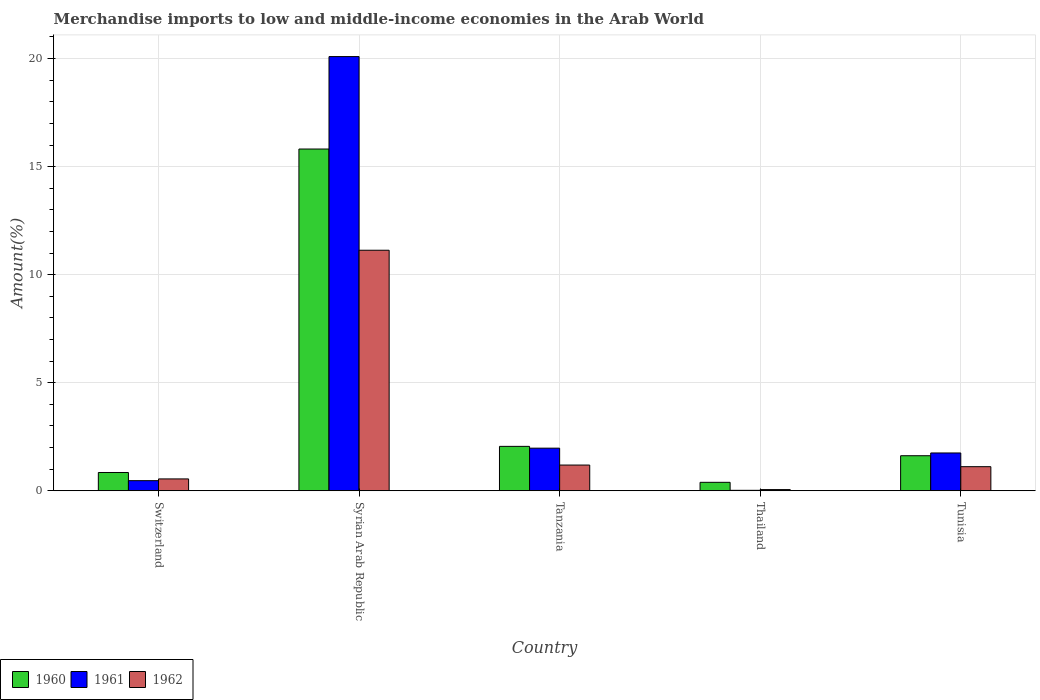How many different coloured bars are there?
Ensure brevity in your answer.  3. How many groups of bars are there?
Provide a succinct answer. 5. Are the number of bars on each tick of the X-axis equal?
Offer a very short reply. Yes. How many bars are there on the 4th tick from the right?
Provide a succinct answer. 3. What is the label of the 3rd group of bars from the left?
Ensure brevity in your answer.  Tanzania. In how many cases, is the number of bars for a given country not equal to the number of legend labels?
Keep it short and to the point. 0. What is the percentage of amount earned from merchandise imports in 1960 in Thailand?
Ensure brevity in your answer.  0.39. Across all countries, what is the maximum percentage of amount earned from merchandise imports in 1960?
Offer a terse response. 15.81. Across all countries, what is the minimum percentage of amount earned from merchandise imports in 1960?
Ensure brevity in your answer.  0.39. In which country was the percentage of amount earned from merchandise imports in 1962 maximum?
Give a very brief answer. Syrian Arab Republic. In which country was the percentage of amount earned from merchandise imports in 1960 minimum?
Your answer should be compact. Thailand. What is the total percentage of amount earned from merchandise imports in 1960 in the graph?
Offer a terse response. 20.73. What is the difference between the percentage of amount earned from merchandise imports in 1962 in Tanzania and that in Tunisia?
Provide a succinct answer. 0.08. What is the difference between the percentage of amount earned from merchandise imports in 1961 in Switzerland and the percentage of amount earned from merchandise imports in 1962 in Tunisia?
Provide a succinct answer. -0.65. What is the average percentage of amount earned from merchandise imports in 1961 per country?
Provide a short and direct response. 4.86. What is the difference between the percentage of amount earned from merchandise imports of/in 1962 and percentage of amount earned from merchandise imports of/in 1960 in Tunisia?
Ensure brevity in your answer.  -0.51. What is the ratio of the percentage of amount earned from merchandise imports in 1960 in Syrian Arab Republic to that in Tunisia?
Provide a succinct answer. 9.75. Is the percentage of amount earned from merchandise imports in 1960 in Syrian Arab Republic less than that in Tunisia?
Provide a short and direct response. No. Is the difference between the percentage of amount earned from merchandise imports in 1962 in Syrian Arab Republic and Tunisia greater than the difference between the percentage of amount earned from merchandise imports in 1960 in Syrian Arab Republic and Tunisia?
Ensure brevity in your answer.  No. What is the difference between the highest and the second highest percentage of amount earned from merchandise imports in 1962?
Keep it short and to the point. -9.94. What is the difference between the highest and the lowest percentage of amount earned from merchandise imports in 1960?
Provide a short and direct response. 15.42. In how many countries, is the percentage of amount earned from merchandise imports in 1962 greater than the average percentage of amount earned from merchandise imports in 1962 taken over all countries?
Your answer should be compact. 1. Is the sum of the percentage of amount earned from merchandise imports in 1961 in Thailand and Tunisia greater than the maximum percentage of amount earned from merchandise imports in 1960 across all countries?
Your answer should be very brief. No. Is it the case that in every country, the sum of the percentage of amount earned from merchandise imports in 1962 and percentage of amount earned from merchandise imports in 1960 is greater than the percentage of amount earned from merchandise imports in 1961?
Your answer should be very brief. Yes. How many countries are there in the graph?
Provide a succinct answer. 5. Does the graph contain any zero values?
Offer a very short reply. No. Does the graph contain grids?
Your response must be concise. Yes. How are the legend labels stacked?
Provide a short and direct response. Horizontal. What is the title of the graph?
Give a very brief answer. Merchandise imports to low and middle-income economies in the Arab World. Does "2003" appear as one of the legend labels in the graph?
Provide a short and direct response. No. What is the label or title of the X-axis?
Offer a very short reply. Country. What is the label or title of the Y-axis?
Make the answer very short. Amount(%). What is the Amount(%) of 1960 in Switzerland?
Offer a terse response. 0.85. What is the Amount(%) of 1961 in Switzerland?
Your response must be concise. 0.47. What is the Amount(%) of 1962 in Switzerland?
Offer a terse response. 0.55. What is the Amount(%) in 1960 in Syrian Arab Republic?
Your answer should be compact. 15.81. What is the Amount(%) in 1961 in Syrian Arab Republic?
Keep it short and to the point. 20.09. What is the Amount(%) of 1962 in Syrian Arab Republic?
Offer a very short reply. 11.13. What is the Amount(%) in 1960 in Tanzania?
Offer a very short reply. 2.06. What is the Amount(%) of 1961 in Tanzania?
Offer a terse response. 1.97. What is the Amount(%) of 1962 in Tanzania?
Offer a terse response. 1.19. What is the Amount(%) of 1960 in Thailand?
Your response must be concise. 0.39. What is the Amount(%) of 1961 in Thailand?
Offer a very short reply. 0.02. What is the Amount(%) in 1962 in Thailand?
Provide a succinct answer. 0.06. What is the Amount(%) in 1960 in Tunisia?
Provide a short and direct response. 1.62. What is the Amount(%) of 1961 in Tunisia?
Ensure brevity in your answer.  1.75. What is the Amount(%) of 1962 in Tunisia?
Offer a terse response. 1.12. Across all countries, what is the maximum Amount(%) of 1960?
Make the answer very short. 15.81. Across all countries, what is the maximum Amount(%) of 1961?
Your answer should be compact. 20.09. Across all countries, what is the maximum Amount(%) of 1962?
Give a very brief answer. 11.13. Across all countries, what is the minimum Amount(%) of 1960?
Your response must be concise. 0.39. Across all countries, what is the minimum Amount(%) of 1961?
Your response must be concise. 0.02. Across all countries, what is the minimum Amount(%) of 1962?
Your response must be concise. 0.06. What is the total Amount(%) of 1960 in the graph?
Offer a very short reply. 20.73. What is the total Amount(%) in 1961 in the graph?
Keep it short and to the point. 24.3. What is the total Amount(%) in 1962 in the graph?
Your answer should be very brief. 14.04. What is the difference between the Amount(%) of 1960 in Switzerland and that in Syrian Arab Republic?
Provide a short and direct response. -14.97. What is the difference between the Amount(%) in 1961 in Switzerland and that in Syrian Arab Republic?
Make the answer very short. -19.62. What is the difference between the Amount(%) of 1962 in Switzerland and that in Syrian Arab Republic?
Give a very brief answer. -10.58. What is the difference between the Amount(%) in 1960 in Switzerland and that in Tanzania?
Offer a very short reply. -1.21. What is the difference between the Amount(%) in 1961 in Switzerland and that in Tanzania?
Keep it short and to the point. -1.5. What is the difference between the Amount(%) of 1962 in Switzerland and that in Tanzania?
Give a very brief answer. -0.64. What is the difference between the Amount(%) in 1960 in Switzerland and that in Thailand?
Ensure brevity in your answer.  0.45. What is the difference between the Amount(%) of 1961 in Switzerland and that in Thailand?
Provide a succinct answer. 0.45. What is the difference between the Amount(%) in 1962 in Switzerland and that in Thailand?
Provide a short and direct response. 0.49. What is the difference between the Amount(%) of 1960 in Switzerland and that in Tunisia?
Offer a very short reply. -0.78. What is the difference between the Amount(%) in 1961 in Switzerland and that in Tunisia?
Offer a very short reply. -1.28. What is the difference between the Amount(%) of 1962 in Switzerland and that in Tunisia?
Your response must be concise. -0.57. What is the difference between the Amount(%) of 1960 in Syrian Arab Republic and that in Tanzania?
Give a very brief answer. 13.76. What is the difference between the Amount(%) of 1961 in Syrian Arab Republic and that in Tanzania?
Provide a short and direct response. 18.12. What is the difference between the Amount(%) of 1962 in Syrian Arab Republic and that in Tanzania?
Give a very brief answer. 9.94. What is the difference between the Amount(%) in 1960 in Syrian Arab Republic and that in Thailand?
Ensure brevity in your answer.  15.42. What is the difference between the Amount(%) of 1961 in Syrian Arab Republic and that in Thailand?
Your answer should be very brief. 20.07. What is the difference between the Amount(%) in 1962 in Syrian Arab Republic and that in Thailand?
Provide a succinct answer. 11.07. What is the difference between the Amount(%) of 1960 in Syrian Arab Republic and that in Tunisia?
Make the answer very short. 14.19. What is the difference between the Amount(%) of 1961 in Syrian Arab Republic and that in Tunisia?
Keep it short and to the point. 18.34. What is the difference between the Amount(%) in 1962 in Syrian Arab Republic and that in Tunisia?
Keep it short and to the point. 10.01. What is the difference between the Amount(%) of 1960 in Tanzania and that in Thailand?
Make the answer very short. 1.66. What is the difference between the Amount(%) of 1961 in Tanzania and that in Thailand?
Give a very brief answer. 1.95. What is the difference between the Amount(%) in 1962 in Tanzania and that in Thailand?
Give a very brief answer. 1.13. What is the difference between the Amount(%) of 1960 in Tanzania and that in Tunisia?
Offer a terse response. 0.43. What is the difference between the Amount(%) in 1961 in Tanzania and that in Tunisia?
Your response must be concise. 0.22. What is the difference between the Amount(%) in 1962 in Tanzania and that in Tunisia?
Ensure brevity in your answer.  0.08. What is the difference between the Amount(%) of 1960 in Thailand and that in Tunisia?
Your answer should be compact. -1.23. What is the difference between the Amount(%) in 1961 in Thailand and that in Tunisia?
Make the answer very short. -1.73. What is the difference between the Amount(%) of 1962 in Thailand and that in Tunisia?
Make the answer very short. -1.06. What is the difference between the Amount(%) in 1960 in Switzerland and the Amount(%) in 1961 in Syrian Arab Republic?
Offer a very short reply. -19.25. What is the difference between the Amount(%) in 1960 in Switzerland and the Amount(%) in 1962 in Syrian Arab Republic?
Offer a very short reply. -10.28. What is the difference between the Amount(%) of 1961 in Switzerland and the Amount(%) of 1962 in Syrian Arab Republic?
Give a very brief answer. -10.66. What is the difference between the Amount(%) of 1960 in Switzerland and the Amount(%) of 1961 in Tanzania?
Keep it short and to the point. -1.13. What is the difference between the Amount(%) of 1960 in Switzerland and the Amount(%) of 1962 in Tanzania?
Provide a succinct answer. -0.34. What is the difference between the Amount(%) in 1961 in Switzerland and the Amount(%) in 1962 in Tanzania?
Your response must be concise. -0.72. What is the difference between the Amount(%) of 1960 in Switzerland and the Amount(%) of 1961 in Thailand?
Your response must be concise. 0.82. What is the difference between the Amount(%) in 1960 in Switzerland and the Amount(%) in 1962 in Thailand?
Provide a succinct answer. 0.79. What is the difference between the Amount(%) of 1961 in Switzerland and the Amount(%) of 1962 in Thailand?
Provide a short and direct response. 0.41. What is the difference between the Amount(%) of 1960 in Switzerland and the Amount(%) of 1961 in Tunisia?
Your response must be concise. -0.9. What is the difference between the Amount(%) in 1960 in Switzerland and the Amount(%) in 1962 in Tunisia?
Offer a terse response. -0.27. What is the difference between the Amount(%) in 1961 in Switzerland and the Amount(%) in 1962 in Tunisia?
Keep it short and to the point. -0.65. What is the difference between the Amount(%) in 1960 in Syrian Arab Republic and the Amount(%) in 1961 in Tanzania?
Offer a very short reply. 13.84. What is the difference between the Amount(%) of 1960 in Syrian Arab Republic and the Amount(%) of 1962 in Tanzania?
Ensure brevity in your answer.  14.62. What is the difference between the Amount(%) in 1961 in Syrian Arab Republic and the Amount(%) in 1962 in Tanzania?
Your answer should be compact. 18.9. What is the difference between the Amount(%) in 1960 in Syrian Arab Republic and the Amount(%) in 1961 in Thailand?
Provide a succinct answer. 15.79. What is the difference between the Amount(%) in 1960 in Syrian Arab Republic and the Amount(%) in 1962 in Thailand?
Make the answer very short. 15.76. What is the difference between the Amount(%) of 1961 in Syrian Arab Republic and the Amount(%) of 1962 in Thailand?
Your response must be concise. 20.04. What is the difference between the Amount(%) of 1960 in Syrian Arab Republic and the Amount(%) of 1961 in Tunisia?
Provide a succinct answer. 14.06. What is the difference between the Amount(%) in 1960 in Syrian Arab Republic and the Amount(%) in 1962 in Tunisia?
Provide a succinct answer. 14.7. What is the difference between the Amount(%) of 1961 in Syrian Arab Republic and the Amount(%) of 1962 in Tunisia?
Offer a terse response. 18.98. What is the difference between the Amount(%) in 1960 in Tanzania and the Amount(%) in 1961 in Thailand?
Your answer should be very brief. 2.03. What is the difference between the Amount(%) of 1960 in Tanzania and the Amount(%) of 1962 in Thailand?
Your response must be concise. 2. What is the difference between the Amount(%) of 1961 in Tanzania and the Amount(%) of 1962 in Thailand?
Keep it short and to the point. 1.92. What is the difference between the Amount(%) in 1960 in Tanzania and the Amount(%) in 1961 in Tunisia?
Provide a short and direct response. 0.31. What is the difference between the Amount(%) in 1960 in Tanzania and the Amount(%) in 1962 in Tunisia?
Provide a short and direct response. 0.94. What is the difference between the Amount(%) of 1961 in Tanzania and the Amount(%) of 1962 in Tunisia?
Ensure brevity in your answer.  0.86. What is the difference between the Amount(%) in 1960 in Thailand and the Amount(%) in 1961 in Tunisia?
Your response must be concise. -1.36. What is the difference between the Amount(%) of 1960 in Thailand and the Amount(%) of 1962 in Tunisia?
Ensure brevity in your answer.  -0.72. What is the difference between the Amount(%) of 1961 in Thailand and the Amount(%) of 1962 in Tunisia?
Your answer should be very brief. -1.09. What is the average Amount(%) in 1960 per country?
Offer a very short reply. 4.15. What is the average Amount(%) in 1961 per country?
Your answer should be compact. 4.86. What is the average Amount(%) in 1962 per country?
Provide a succinct answer. 2.81. What is the difference between the Amount(%) of 1960 and Amount(%) of 1961 in Switzerland?
Your answer should be compact. 0.38. What is the difference between the Amount(%) of 1960 and Amount(%) of 1962 in Switzerland?
Your response must be concise. 0.3. What is the difference between the Amount(%) in 1961 and Amount(%) in 1962 in Switzerland?
Your answer should be compact. -0.08. What is the difference between the Amount(%) in 1960 and Amount(%) in 1961 in Syrian Arab Republic?
Ensure brevity in your answer.  -4.28. What is the difference between the Amount(%) of 1960 and Amount(%) of 1962 in Syrian Arab Republic?
Ensure brevity in your answer.  4.68. What is the difference between the Amount(%) of 1961 and Amount(%) of 1962 in Syrian Arab Republic?
Offer a very short reply. 8.96. What is the difference between the Amount(%) of 1960 and Amount(%) of 1961 in Tanzania?
Your answer should be very brief. 0.08. What is the difference between the Amount(%) of 1960 and Amount(%) of 1962 in Tanzania?
Your answer should be compact. 0.87. What is the difference between the Amount(%) in 1961 and Amount(%) in 1962 in Tanzania?
Ensure brevity in your answer.  0.78. What is the difference between the Amount(%) of 1960 and Amount(%) of 1961 in Thailand?
Your response must be concise. 0.37. What is the difference between the Amount(%) in 1960 and Amount(%) in 1962 in Thailand?
Your answer should be compact. 0.34. What is the difference between the Amount(%) of 1961 and Amount(%) of 1962 in Thailand?
Your answer should be very brief. -0.03. What is the difference between the Amount(%) in 1960 and Amount(%) in 1961 in Tunisia?
Your response must be concise. -0.13. What is the difference between the Amount(%) in 1960 and Amount(%) in 1962 in Tunisia?
Your answer should be very brief. 0.51. What is the difference between the Amount(%) in 1961 and Amount(%) in 1962 in Tunisia?
Offer a very short reply. 0.64. What is the ratio of the Amount(%) of 1960 in Switzerland to that in Syrian Arab Republic?
Offer a terse response. 0.05. What is the ratio of the Amount(%) of 1961 in Switzerland to that in Syrian Arab Republic?
Keep it short and to the point. 0.02. What is the ratio of the Amount(%) of 1962 in Switzerland to that in Syrian Arab Republic?
Your response must be concise. 0.05. What is the ratio of the Amount(%) of 1960 in Switzerland to that in Tanzania?
Keep it short and to the point. 0.41. What is the ratio of the Amount(%) in 1961 in Switzerland to that in Tanzania?
Offer a very short reply. 0.24. What is the ratio of the Amount(%) of 1962 in Switzerland to that in Tanzania?
Ensure brevity in your answer.  0.46. What is the ratio of the Amount(%) of 1960 in Switzerland to that in Thailand?
Your response must be concise. 2.16. What is the ratio of the Amount(%) of 1961 in Switzerland to that in Thailand?
Ensure brevity in your answer.  21.93. What is the ratio of the Amount(%) of 1962 in Switzerland to that in Thailand?
Your answer should be compact. 9.89. What is the ratio of the Amount(%) in 1960 in Switzerland to that in Tunisia?
Offer a very short reply. 0.52. What is the ratio of the Amount(%) of 1961 in Switzerland to that in Tunisia?
Offer a terse response. 0.27. What is the ratio of the Amount(%) in 1962 in Switzerland to that in Tunisia?
Provide a short and direct response. 0.49. What is the ratio of the Amount(%) in 1960 in Syrian Arab Republic to that in Tanzania?
Offer a terse response. 7.69. What is the ratio of the Amount(%) of 1961 in Syrian Arab Republic to that in Tanzania?
Make the answer very short. 10.19. What is the ratio of the Amount(%) of 1962 in Syrian Arab Republic to that in Tanzania?
Ensure brevity in your answer.  9.35. What is the ratio of the Amount(%) in 1960 in Syrian Arab Republic to that in Thailand?
Ensure brevity in your answer.  40.37. What is the ratio of the Amount(%) in 1961 in Syrian Arab Republic to that in Thailand?
Offer a very short reply. 941.08. What is the ratio of the Amount(%) in 1962 in Syrian Arab Republic to that in Thailand?
Keep it short and to the point. 200.38. What is the ratio of the Amount(%) of 1960 in Syrian Arab Republic to that in Tunisia?
Keep it short and to the point. 9.75. What is the ratio of the Amount(%) of 1961 in Syrian Arab Republic to that in Tunisia?
Your answer should be very brief. 11.48. What is the ratio of the Amount(%) of 1962 in Syrian Arab Republic to that in Tunisia?
Ensure brevity in your answer.  9.98. What is the ratio of the Amount(%) of 1960 in Tanzania to that in Thailand?
Your answer should be very brief. 5.25. What is the ratio of the Amount(%) in 1961 in Tanzania to that in Thailand?
Keep it short and to the point. 92.38. What is the ratio of the Amount(%) in 1962 in Tanzania to that in Thailand?
Your answer should be compact. 21.43. What is the ratio of the Amount(%) of 1960 in Tanzania to that in Tunisia?
Keep it short and to the point. 1.27. What is the ratio of the Amount(%) of 1961 in Tanzania to that in Tunisia?
Your response must be concise. 1.13. What is the ratio of the Amount(%) of 1962 in Tanzania to that in Tunisia?
Your answer should be very brief. 1.07. What is the ratio of the Amount(%) in 1960 in Thailand to that in Tunisia?
Offer a terse response. 0.24. What is the ratio of the Amount(%) in 1961 in Thailand to that in Tunisia?
Make the answer very short. 0.01. What is the ratio of the Amount(%) in 1962 in Thailand to that in Tunisia?
Give a very brief answer. 0.05. What is the difference between the highest and the second highest Amount(%) of 1960?
Ensure brevity in your answer.  13.76. What is the difference between the highest and the second highest Amount(%) in 1961?
Keep it short and to the point. 18.12. What is the difference between the highest and the second highest Amount(%) of 1962?
Provide a succinct answer. 9.94. What is the difference between the highest and the lowest Amount(%) in 1960?
Your response must be concise. 15.42. What is the difference between the highest and the lowest Amount(%) of 1961?
Keep it short and to the point. 20.07. What is the difference between the highest and the lowest Amount(%) of 1962?
Offer a very short reply. 11.07. 